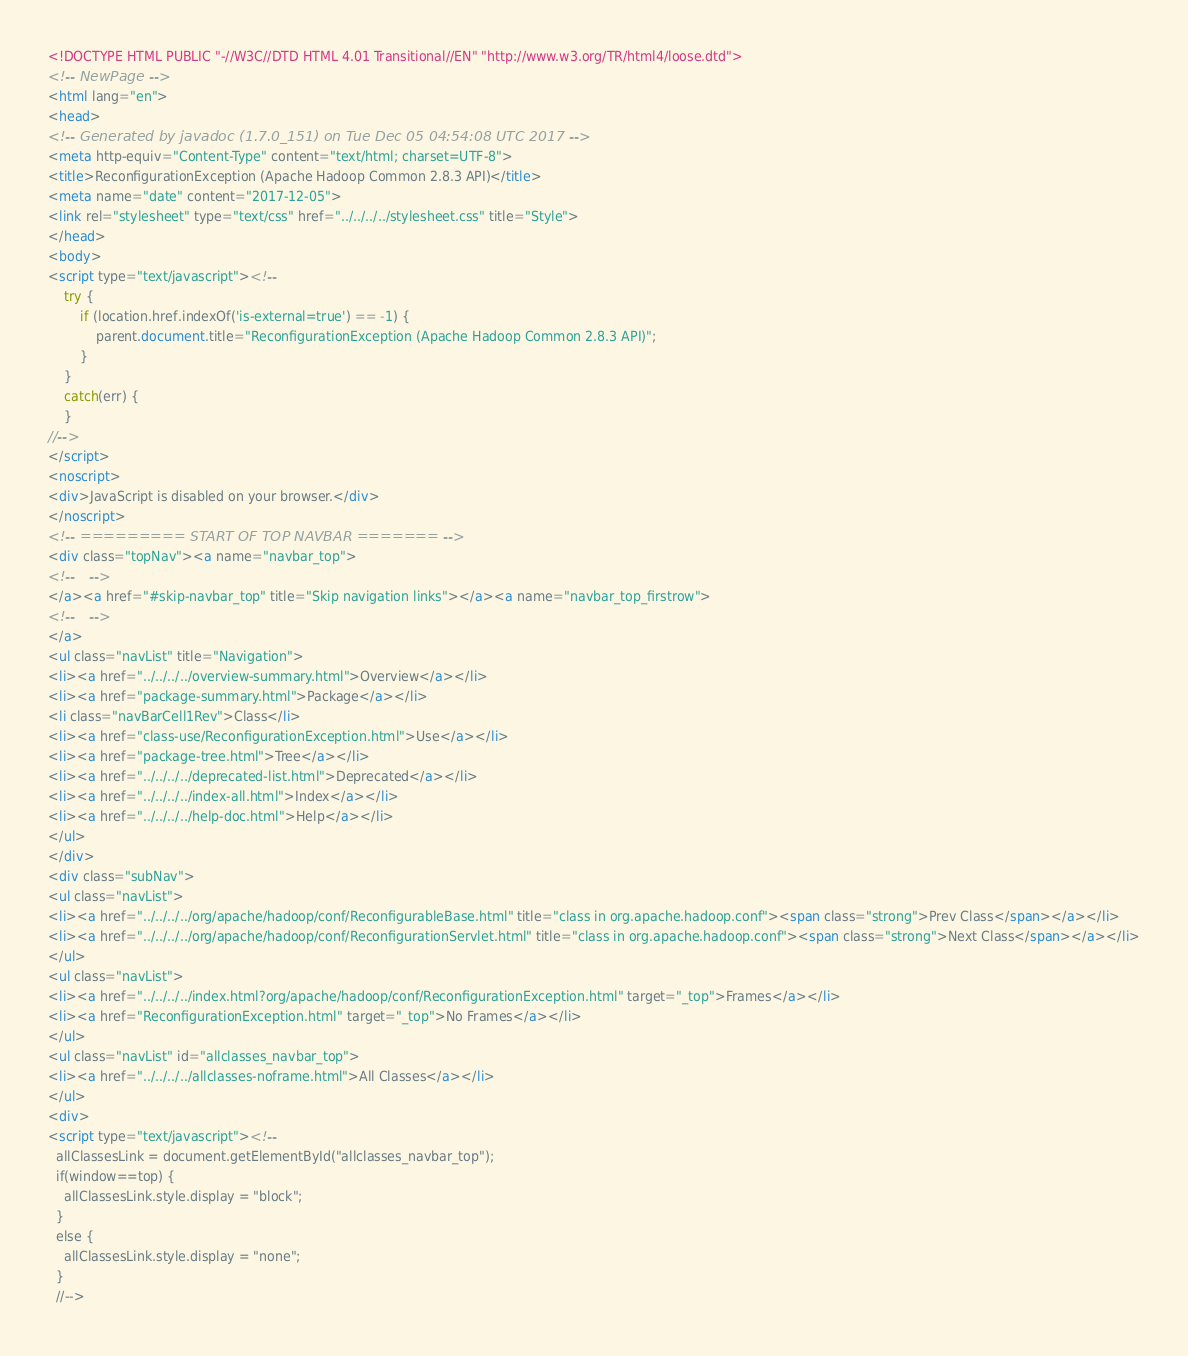<code> <loc_0><loc_0><loc_500><loc_500><_HTML_><!DOCTYPE HTML PUBLIC "-//W3C//DTD HTML 4.01 Transitional//EN" "http://www.w3.org/TR/html4/loose.dtd">
<!-- NewPage -->
<html lang="en">
<head>
<!-- Generated by javadoc (1.7.0_151) on Tue Dec 05 04:54:08 UTC 2017 -->
<meta http-equiv="Content-Type" content="text/html; charset=UTF-8">
<title>ReconfigurationException (Apache Hadoop Common 2.8.3 API)</title>
<meta name="date" content="2017-12-05">
<link rel="stylesheet" type="text/css" href="../../../../stylesheet.css" title="Style">
</head>
<body>
<script type="text/javascript"><!--
    try {
        if (location.href.indexOf('is-external=true') == -1) {
            parent.document.title="ReconfigurationException (Apache Hadoop Common 2.8.3 API)";
        }
    }
    catch(err) {
    }
//-->
</script>
<noscript>
<div>JavaScript is disabled on your browser.</div>
</noscript>
<!-- ========= START OF TOP NAVBAR ======= -->
<div class="topNav"><a name="navbar_top">
<!--   -->
</a><a href="#skip-navbar_top" title="Skip navigation links"></a><a name="navbar_top_firstrow">
<!--   -->
</a>
<ul class="navList" title="Navigation">
<li><a href="../../../../overview-summary.html">Overview</a></li>
<li><a href="package-summary.html">Package</a></li>
<li class="navBarCell1Rev">Class</li>
<li><a href="class-use/ReconfigurationException.html">Use</a></li>
<li><a href="package-tree.html">Tree</a></li>
<li><a href="../../../../deprecated-list.html">Deprecated</a></li>
<li><a href="../../../../index-all.html">Index</a></li>
<li><a href="../../../../help-doc.html">Help</a></li>
</ul>
</div>
<div class="subNav">
<ul class="navList">
<li><a href="../../../../org/apache/hadoop/conf/ReconfigurableBase.html" title="class in org.apache.hadoop.conf"><span class="strong">Prev Class</span></a></li>
<li><a href="../../../../org/apache/hadoop/conf/ReconfigurationServlet.html" title="class in org.apache.hadoop.conf"><span class="strong">Next Class</span></a></li>
</ul>
<ul class="navList">
<li><a href="../../../../index.html?org/apache/hadoop/conf/ReconfigurationException.html" target="_top">Frames</a></li>
<li><a href="ReconfigurationException.html" target="_top">No Frames</a></li>
</ul>
<ul class="navList" id="allclasses_navbar_top">
<li><a href="../../../../allclasses-noframe.html">All Classes</a></li>
</ul>
<div>
<script type="text/javascript"><!--
  allClassesLink = document.getElementById("allclasses_navbar_top");
  if(window==top) {
    allClassesLink.style.display = "block";
  }
  else {
    allClassesLink.style.display = "none";
  }
  //--></code> 